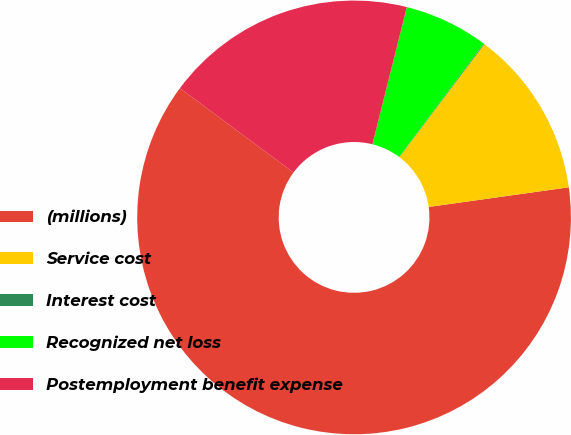<chart> <loc_0><loc_0><loc_500><loc_500><pie_chart><fcel>(millions)<fcel>Service cost<fcel>Interest cost<fcel>Recognized net loss<fcel>Postemployment benefit expense<nl><fcel>62.37%<fcel>12.52%<fcel>0.06%<fcel>6.29%<fcel>18.75%<nl></chart> 